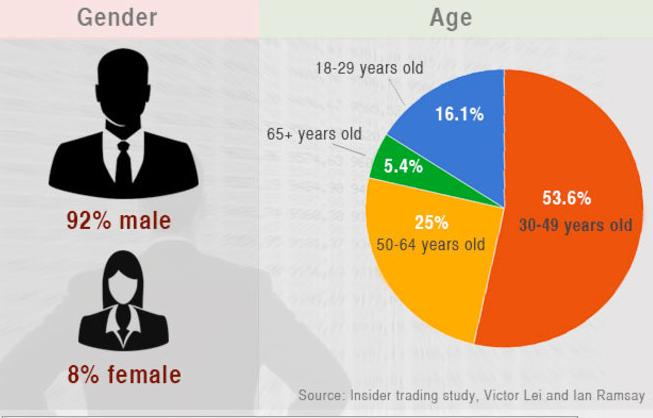Identify some key points in this picture. The color that indicates the percentage of people in the age group of 50 to 64 is yellow. The color blue represents the percentage of individuals in the age group of 18-29 years. According to the data, 69.7% of the population falls within the age range of 18 and 49 years old. The pie chart shows the percentage of senior citizens in the population, and the value is 5.4%. The estimated percentage of individuals aged between 50 and 65 years or older is 30.4%. 